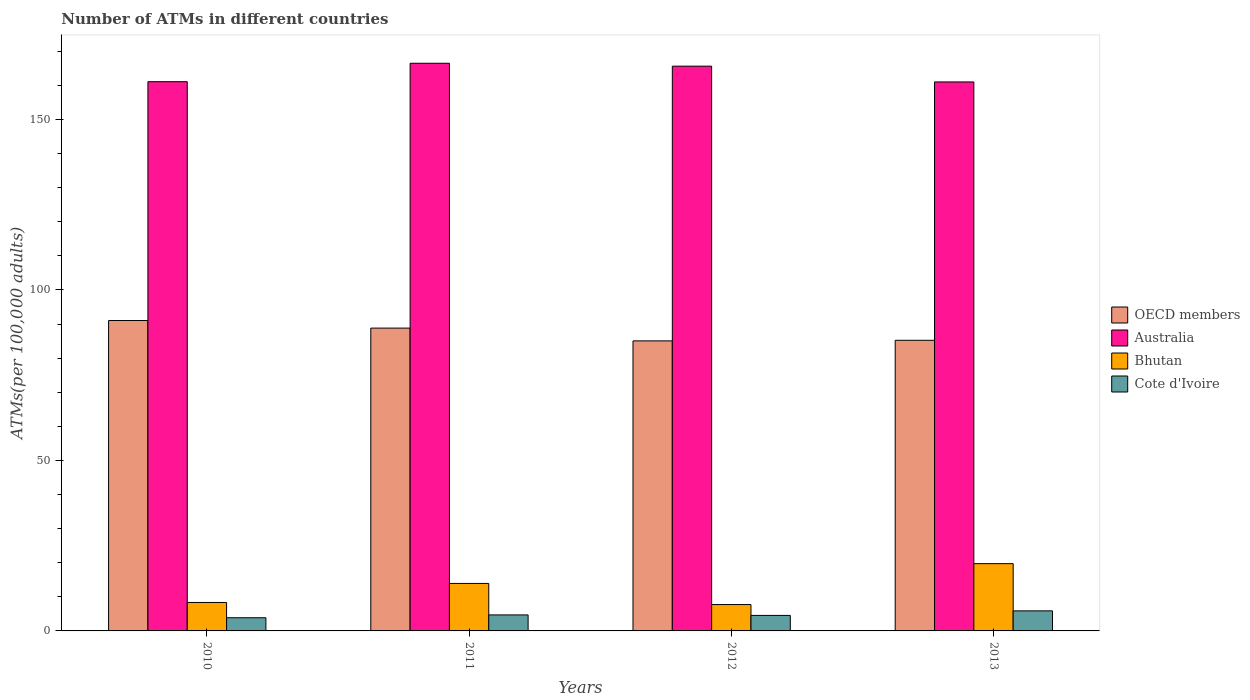How many different coloured bars are there?
Your answer should be very brief. 4. Are the number of bars on each tick of the X-axis equal?
Offer a terse response. Yes. How many bars are there on the 4th tick from the left?
Provide a succinct answer. 4. In how many cases, is the number of bars for a given year not equal to the number of legend labels?
Provide a short and direct response. 0. What is the number of ATMs in Bhutan in 2012?
Ensure brevity in your answer.  7.73. Across all years, what is the maximum number of ATMs in Bhutan?
Give a very brief answer. 19.73. Across all years, what is the minimum number of ATMs in Bhutan?
Your answer should be compact. 7.73. In which year was the number of ATMs in OECD members maximum?
Give a very brief answer. 2010. What is the total number of ATMs in OECD members in the graph?
Provide a succinct answer. 350.12. What is the difference between the number of ATMs in Bhutan in 2012 and that in 2013?
Ensure brevity in your answer.  -11.99. What is the difference between the number of ATMs in Cote d'Ivoire in 2010 and the number of ATMs in Australia in 2013?
Your response must be concise. -157.13. What is the average number of ATMs in Australia per year?
Ensure brevity in your answer.  163.54. In the year 2011, what is the difference between the number of ATMs in OECD members and number of ATMs in Cote d'Ivoire?
Your answer should be compact. 84.11. What is the ratio of the number of ATMs in Cote d'Ivoire in 2011 to that in 2013?
Your answer should be very brief. 0.8. Is the difference between the number of ATMs in OECD members in 2012 and 2013 greater than the difference between the number of ATMs in Cote d'Ivoire in 2012 and 2013?
Ensure brevity in your answer.  Yes. What is the difference between the highest and the second highest number of ATMs in Bhutan?
Give a very brief answer. 5.8. What is the difference between the highest and the lowest number of ATMs in OECD members?
Offer a very short reply. 5.97. Is the sum of the number of ATMs in Bhutan in 2010 and 2011 greater than the maximum number of ATMs in Cote d'Ivoire across all years?
Ensure brevity in your answer.  Yes. Is it the case that in every year, the sum of the number of ATMs in Australia and number of ATMs in Bhutan is greater than the sum of number of ATMs in OECD members and number of ATMs in Cote d'Ivoire?
Provide a short and direct response. Yes. Is it the case that in every year, the sum of the number of ATMs in OECD members and number of ATMs in Bhutan is greater than the number of ATMs in Australia?
Offer a terse response. No. What is the difference between two consecutive major ticks on the Y-axis?
Ensure brevity in your answer.  50. Are the values on the major ticks of Y-axis written in scientific E-notation?
Your answer should be compact. No. Does the graph contain grids?
Provide a succinct answer. No. How are the legend labels stacked?
Your answer should be compact. Vertical. What is the title of the graph?
Make the answer very short. Number of ATMs in different countries. What is the label or title of the Y-axis?
Offer a very short reply. ATMs(per 100,0 adults). What is the ATMs(per 100,000 adults) of OECD members in 2010?
Your answer should be very brief. 91.03. What is the ATMs(per 100,000 adults) of Australia in 2010?
Give a very brief answer. 161.07. What is the ATMs(per 100,000 adults) in Bhutan in 2010?
Your answer should be very brief. 8.34. What is the ATMs(per 100,000 adults) in Cote d'Ivoire in 2010?
Your answer should be very brief. 3.87. What is the ATMs(per 100,000 adults) in OECD members in 2011?
Your answer should be compact. 88.81. What is the ATMs(per 100,000 adults) in Australia in 2011?
Offer a terse response. 166.47. What is the ATMs(per 100,000 adults) in Bhutan in 2011?
Your answer should be very brief. 13.93. What is the ATMs(per 100,000 adults) in Cote d'Ivoire in 2011?
Keep it short and to the point. 4.69. What is the ATMs(per 100,000 adults) in OECD members in 2012?
Offer a very short reply. 85.06. What is the ATMs(per 100,000 adults) in Australia in 2012?
Offer a terse response. 165.62. What is the ATMs(per 100,000 adults) in Bhutan in 2012?
Keep it short and to the point. 7.73. What is the ATMs(per 100,000 adults) in Cote d'Ivoire in 2012?
Provide a short and direct response. 4.55. What is the ATMs(per 100,000 adults) in OECD members in 2013?
Make the answer very short. 85.23. What is the ATMs(per 100,000 adults) in Australia in 2013?
Your response must be concise. 160.99. What is the ATMs(per 100,000 adults) of Bhutan in 2013?
Provide a succinct answer. 19.73. What is the ATMs(per 100,000 adults) in Cote d'Ivoire in 2013?
Give a very brief answer. 5.88. Across all years, what is the maximum ATMs(per 100,000 adults) of OECD members?
Provide a succinct answer. 91.03. Across all years, what is the maximum ATMs(per 100,000 adults) in Australia?
Your answer should be very brief. 166.47. Across all years, what is the maximum ATMs(per 100,000 adults) in Bhutan?
Your answer should be compact. 19.73. Across all years, what is the maximum ATMs(per 100,000 adults) of Cote d'Ivoire?
Offer a very short reply. 5.88. Across all years, what is the minimum ATMs(per 100,000 adults) of OECD members?
Offer a terse response. 85.06. Across all years, what is the minimum ATMs(per 100,000 adults) in Australia?
Offer a terse response. 160.99. Across all years, what is the minimum ATMs(per 100,000 adults) of Bhutan?
Ensure brevity in your answer.  7.73. Across all years, what is the minimum ATMs(per 100,000 adults) of Cote d'Ivoire?
Make the answer very short. 3.87. What is the total ATMs(per 100,000 adults) of OECD members in the graph?
Your answer should be very brief. 350.12. What is the total ATMs(per 100,000 adults) in Australia in the graph?
Give a very brief answer. 654.16. What is the total ATMs(per 100,000 adults) of Bhutan in the graph?
Your response must be concise. 49.73. What is the total ATMs(per 100,000 adults) in Cote d'Ivoire in the graph?
Your response must be concise. 18.99. What is the difference between the ATMs(per 100,000 adults) in OECD members in 2010 and that in 2011?
Your response must be concise. 2.22. What is the difference between the ATMs(per 100,000 adults) in Australia in 2010 and that in 2011?
Offer a very short reply. -5.41. What is the difference between the ATMs(per 100,000 adults) in Bhutan in 2010 and that in 2011?
Your response must be concise. -5.59. What is the difference between the ATMs(per 100,000 adults) in Cote d'Ivoire in 2010 and that in 2011?
Offer a very short reply. -0.83. What is the difference between the ATMs(per 100,000 adults) in OECD members in 2010 and that in 2012?
Ensure brevity in your answer.  5.97. What is the difference between the ATMs(per 100,000 adults) of Australia in 2010 and that in 2012?
Make the answer very short. -4.55. What is the difference between the ATMs(per 100,000 adults) of Bhutan in 2010 and that in 2012?
Make the answer very short. 0.61. What is the difference between the ATMs(per 100,000 adults) in Cote d'Ivoire in 2010 and that in 2012?
Make the answer very short. -0.68. What is the difference between the ATMs(per 100,000 adults) of OECD members in 2010 and that in 2013?
Keep it short and to the point. 5.8. What is the difference between the ATMs(per 100,000 adults) of Australia in 2010 and that in 2013?
Your answer should be compact. 0.07. What is the difference between the ATMs(per 100,000 adults) in Bhutan in 2010 and that in 2013?
Provide a succinct answer. -11.39. What is the difference between the ATMs(per 100,000 adults) of Cote d'Ivoire in 2010 and that in 2013?
Your answer should be compact. -2.01. What is the difference between the ATMs(per 100,000 adults) of OECD members in 2011 and that in 2012?
Provide a succinct answer. 3.75. What is the difference between the ATMs(per 100,000 adults) in Australia in 2011 and that in 2012?
Offer a very short reply. 0.85. What is the difference between the ATMs(per 100,000 adults) of Bhutan in 2011 and that in 2012?
Make the answer very short. 6.19. What is the difference between the ATMs(per 100,000 adults) in Cote d'Ivoire in 2011 and that in 2012?
Provide a succinct answer. 0.15. What is the difference between the ATMs(per 100,000 adults) in OECD members in 2011 and that in 2013?
Your answer should be compact. 3.58. What is the difference between the ATMs(per 100,000 adults) in Australia in 2011 and that in 2013?
Your response must be concise. 5.48. What is the difference between the ATMs(per 100,000 adults) of Bhutan in 2011 and that in 2013?
Offer a very short reply. -5.8. What is the difference between the ATMs(per 100,000 adults) of Cote d'Ivoire in 2011 and that in 2013?
Your answer should be very brief. -1.19. What is the difference between the ATMs(per 100,000 adults) of OECD members in 2012 and that in 2013?
Provide a short and direct response. -0.17. What is the difference between the ATMs(per 100,000 adults) in Australia in 2012 and that in 2013?
Your response must be concise. 4.63. What is the difference between the ATMs(per 100,000 adults) of Bhutan in 2012 and that in 2013?
Provide a short and direct response. -11.99. What is the difference between the ATMs(per 100,000 adults) in Cote d'Ivoire in 2012 and that in 2013?
Offer a terse response. -1.33. What is the difference between the ATMs(per 100,000 adults) of OECD members in 2010 and the ATMs(per 100,000 adults) of Australia in 2011?
Provide a succinct answer. -75.44. What is the difference between the ATMs(per 100,000 adults) of OECD members in 2010 and the ATMs(per 100,000 adults) of Bhutan in 2011?
Your answer should be compact. 77.1. What is the difference between the ATMs(per 100,000 adults) of OECD members in 2010 and the ATMs(per 100,000 adults) of Cote d'Ivoire in 2011?
Ensure brevity in your answer.  86.34. What is the difference between the ATMs(per 100,000 adults) of Australia in 2010 and the ATMs(per 100,000 adults) of Bhutan in 2011?
Your response must be concise. 147.14. What is the difference between the ATMs(per 100,000 adults) of Australia in 2010 and the ATMs(per 100,000 adults) of Cote d'Ivoire in 2011?
Keep it short and to the point. 156.38. What is the difference between the ATMs(per 100,000 adults) in Bhutan in 2010 and the ATMs(per 100,000 adults) in Cote d'Ivoire in 2011?
Keep it short and to the point. 3.65. What is the difference between the ATMs(per 100,000 adults) of OECD members in 2010 and the ATMs(per 100,000 adults) of Australia in 2012?
Your response must be concise. -74.59. What is the difference between the ATMs(per 100,000 adults) of OECD members in 2010 and the ATMs(per 100,000 adults) of Bhutan in 2012?
Your response must be concise. 83.3. What is the difference between the ATMs(per 100,000 adults) of OECD members in 2010 and the ATMs(per 100,000 adults) of Cote d'Ivoire in 2012?
Make the answer very short. 86.48. What is the difference between the ATMs(per 100,000 adults) of Australia in 2010 and the ATMs(per 100,000 adults) of Bhutan in 2012?
Ensure brevity in your answer.  153.34. What is the difference between the ATMs(per 100,000 adults) of Australia in 2010 and the ATMs(per 100,000 adults) of Cote d'Ivoire in 2012?
Provide a succinct answer. 156.52. What is the difference between the ATMs(per 100,000 adults) of Bhutan in 2010 and the ATMs(per 100,000 adults) of Cote d'Ivoire in 2012?
Make the answer very short. 3.79. What is the difference between the ATMs(per 100,000 adults) of OECD members in 2010 and the ATMs(per 100,000 adults) of Australia in 2013?
Your answer should be very brief. -69.97. What is the difference between the ATMs(per 100,000 adults) in OECD members in 2010 and the ATMs(per 100,000 adults) in Bhutan in 2013?
Offer a terse response. 71.3. What is the difference between the ATMs(per 100,000 adults) in OECD members in 2010 and the ATMs(per 100,000 adults) in Cote d'Ivoire in 2013?
Ensure brevity in your answer.  85.15. What is the difference between the ATMs(per 100,000 adults) in Australia in 2010 and the ATMs(per 100,000 adults) in Bhutan in 2013?
Offer a very short reply. 141.34. What is the difference between the ATMs(per 100,000 adults) in Australia in 2010 and the ATMs(per 100,000 adults) in Cote d'Ivoire in 2013?
Provide a succinct answer. 155.19. What is the difference between the ATMs(per 100,000 adults) in Bhutan in 2010 and the ATMs(per 100,000 adults) in Cote d'Ivoire in 2013?
Keep it short and to the point. 2.46. What is the difference between the ATMs(per 100,000 adults) of OECD members in 2011 and the ATMs(per 100,000 adults) of Australia in 2012?
Your response must be concise. -76.82. What is the difference between the ATMs(per 100,000 adults) of OECD members in 2011 and the ATMs(per 100,000 adults) of Bhutan in 2012?
Offer a very short reply. 81.07. What is the difference between the ATMs(per 100,000 adults) of OECD members in 2011 and the ATMs(per 100,000 adults) of Cote d'Ivoire in 2012?
Your response must be concise. 84.26. What is the difference between the ATMs(per 100,000 adults) in Australia in 2011 and the ATMs(per 100,000 adults) in Bhutan in 2012?
Offer a very short reply. 158.74. What is the difference between the ATMs(per 100,000 adults) in Australia in 2011 and the ATMs(per 100,000 adults) in Cote d'Ivoire in 2012?
Keep it short and to the point. 161.93. What is the difference between the ATMs(per 100,000 adults) of Bhutan in 2011 and the ATMs(per 100,000 adults) of Cote d'Ivoire in 2012?
Keep it short and to the point. 9.38. What is the difference between the ATMs(per 100,000 adults) in OECD members in 2011 and the ATMs(per 100,000 adults) in Australia in 2013?
Give a very brief answer. -72.19. What is the difference between the ATMs(per 100,000 adults) of OECD members in 2011 and the ATMs(per 100,000 adults) of Bhutan in 2013?
Provide a short and direct response. 69.08. What is the difference between the ATMs(per 100,000 adults) of OECD members in 2011 and the ATMs(per 100,000 adults) of Cote d'Ivoire in 2013?
Give a very brief answer. 82.92. What is the difference between the ATMs(per 100,000 adults) in Australia in 2011 and the ATMs(per 100,000 adults) in Bhutan in 2013?
Make the answer very short. 146.75. What is the difference between the ATMs(per 100,000 adults) of Australia in 2011 and the ATMs(per 100,000 adults) of Cote d'Ivoire in 2013?
Give a very brief answer. 160.59. What is the difference between the ATMs(per 100,000 adults) in Bhutan in 2011 and the ATMs(per 100,000 adults) in Cote d'Ivoire in 2013?
Give a very brief answer. 8.04. What is the difference between the ATMs(per 100,000 adults) in OECD members in 2012 and the ATMs(per 100,000 adults) in Australia in 2013?
Give a very brief answer. -75.94. What is the difference between the ATMs(per 100,000 adults) in OECD members in 2012 and the ATMs(per 100,000 adults) in Bhutan in 2013?
Provide a short and direct response. 65.33. What is the difference between the ATMs(per 100,000 adults) in OECD members in 2012 and the ATMs(per 100,000 adults) in Cote d'Ivoire in 2013?
Offer a very short reply. 79.18. What is the difference between the ATMs(per 100,000 adults) of Australia in 2012 and the ATMs(per 100,000 adults) of Bhutan in 2013?
Give a very brief answer. 145.89. What is the difference between the ATMs(per 100,000 adults) in Australia in 2012 and the ATMs(per 100,000 adults) in Cote d'Ivoire in 2013?
Give a very brief answer. 159.74. What is the difference between the ATMs(per 100,000 adults) of Bhutan in 2012 and the ATMs(per 100,000 adults) of Cote d'Ivoire in 2013?
Ensure brevity in your answer.  1.85. What is the average ATMs(per 100,000 adults) in OECD members per year?
Offer a terse response. 87.53. What is the average ATMs(per 100,000 adults) of Australia per year?
Ensure brevity in your answer.  163.54. What is the average ATMs(per 100,000 adults) in Bhutan per year?
Keep it short and to the point. 12.43. What is the average ATMs(per 100,000 adults) of Cote d'Ivoire per year?
Make the answer very short. 4.75. In the year 2010, what is the difference between the ATMs(per 100,000 adults) in OECD members and ATMs(per 100,000 adults) in Australia?
Keep it short and to the point. -70.04. In the year 2010, what is the difference between the ATMs(per 100,000 adults) in OECD members and ATMs(per 100,000 adults) in Bhutan?
Keep it short and to the point. 82.69. In the year 2010, what is the difference between the ATMs(per 100,000 adults) in OECD members and ATMs(per 100,000 adults) in Cote d'Ivoire?
Your answer should be very brief. 87.16. In the year 2010, what is the difference between the ATMs(per 100,000 adults) in Australia and ATMs(per 100,000 adults) in Bhutan?
Offer a terse response. 152.73. In the year 2010, what is the difference between the ATMs(per 100,000 adults) of Australia and ATMs(per 100,000 adults) of Cote d'Ivoire?
Provide a succinct answer. 157.2. In the year 2010, what is the difference between the ATMs(per 100,000 adults) in Bhutan and ATMs(per 100,000 adults) in Cote d'Ivoire?
Provide a succinct answer. 4.47. In the year 2011, what is the difference between the ATMs(per 100,000 adults) in OECD members and ATMs(per 100,000 adults) in Australia?
Provide a succinct answer. -77.67. In the year 2011, what is the difference between the ATMs(per 100,000 adults) in OECD members and ATMs(per 100,000 adults) in Bhutan?
Give a very brief answer. 74.88. In the year 2011, what is the difference between the ATMs(per 100,000 adults) of OECD members and ATMs(per 100,000 adults) of Cote d'Ivoire?
Your answer should be compact. 84.11. In the year 2011, what is the difference between the ATMs(per 100,000 adults) in Australia and ATMs(per 100,000 adults) in Bhutan?
Offer a terse response. 152.55. In the year 2011, what is the difference between the ATMs(per 100,000 adults) in Australia and ATMs(per 100,000 adults) in Cote d'Ivoire?
Keep it short and to the point. 161.78. In the year 2011, what is the difference between the ATMs(per 100,000 adults) of Bhutan and ATMs(per 100,000 adults) of Cote d'Ivoire?
Give a very brief answer. 9.23. In the year 2012, what is the difference between the ATMs(per 100,000 adults) in OECD members and ATMs(per 100,000 adults) in Australia?
Provide a succinct answer. -80.56. In the year 2012, what is the difference between the ATMs(per 100,000 adults) of OECD members and ATMs(per 100,000 adults) of Bhutan?
Provide a short and direct response. 77.32. In the year 2012, what is the difference between the ATMs(per 100,000 adults) in OECD members and ATMs(per 100,000 adults) in Cote d'Ivoire?
Ensure brevity in your answer.  80.51. In the year 2012, what is the difference between the ATMs(per 100,000 adults) in Australia and ATMs(per 100,000 adults) in Bhutan?
Provide a succinct answer. 157.89. In the year 2012, what is the difference between the ATMs(per 100,000 adults) of Australia and ATMs(per 100,000 adults) of Cote d'Ivoire?
Give a very brief answer. 161.07. In the year 2012, what is the difference between the ATMs(per 100,000 adults) in Bhutan and ATMs(per 100,000 adults) in Cote d'Ivoire?
Keep it short and to the point. 3.19. In the year 2013, what is the difference between the ATMs(per 100,000 adults) of OECD members and ATMs(per 100,000 adults) of Australia?
Offer a terse response. -75.77. In the year 2013, what is the difference between the ATMs(per 100,000 adults) of OECD members and ATMs(per 100,000 adults) of Bhutan?
Offer a terse response. 65.5. In the year 2013, what is the difference between the ATMs(per 100,000 adults) in OECD members and ATMs(per 100,000 adults) in Cote d'Ivoire?
Your answer should be compact. 79.34. In the year 2013, what is the difference between the ATMs(per 100,000 adults) in Australia and ATMs(per 100,000 adults) in Bhutan?
Provide a succinct answer. 141.27. In the year 2013, what is the difference between the ATMs(per 100,000 adults) in Australia and ATMs(per 100,000 adults) in Cote d'Ivoire?
Keep it short and to the point. 155.11. In the year 2013, what is the difference between the ATMs(per 100,000 adults) of Bhutan and ATMs(per 100,000 adults) of Cote d'Ivoire?
Keep it short and to the point. 13.85. What is the ratio of the ATMs(per 100,000 adults) of OECD members in 2010 to that in 2011?
Ensure brevity in your answer.  1.02. What is the ratio of the ATMs(per 100,000 adults) of Australia in 2010 to that in 2011?
Keep it short and to the point. 0.97. What is the ratio of the ATMs(per 100,000 adults) in Bhutan in 2010 to that in 2011?
Keep it short and to the point. 0.6. What is the ratio of the ATMs(per 100,000 adults) in Cote d'Ivoire in 2010 to that in 2011?
Your response must be concise. 0.82. What is the ratio of the ATMs(per 100,000 adults) of OECD members in 2010 to that in 2012?
Provide a short and direct response. 1.07. What is the ratio of the ATMs(per 100,000 adults) in Australia in 2010 to that in 2012?
Ensure brevity in your answer.  0.97. What is the ratio of the ATMs(per 100,000 adults) in Bhutan in 2010 to that in 2012?
Provide a succinct answer. 1.08. What is the ratio of the ATMs(per 100,000 adults) of Cote d'Ivoire in 2010 to that in 2012?
Provide a short and direct response. 0.85. What is the ratio of the ATMs(per 100,000 adults) in OECD members in 2010 to that in 2013?
Keep it short and to the point. 1.07. What is the ratio of the ATMs(per 100,000 adults) of Bhutan in 2010 to that in 2013?
Offer a terse response. 0.42. What is the ratio of the ATMs(per 100,000 adults) in Cote d'Ivoire in 2010 to that in 2013?
Your answer should be very brief. 0.66. What is the ratio of the ATMs(per 100,000 adults) of OECD members in 2011 to that in 2012?
Provide a succinct answer. 1.04. What is the ratio of the ATMs(per 100,000 adults) of Bhutan in 2011 to that in 2012?
Provide a succinct answer. 1.8. What is the ratio of the ATMs(per 100,000 adults) in Cote d'Ivoire in 2011 to that in 2012?
Offer a very short reply. 1.03. What is the ratio of the ATMs(per 100,000 adults) in OECD members in 2011 to that in 2013?
Offer a terse response. 1.04. What is the ratio of the ATMs(per 100,000 adults) in Australia in 2011 to that in 2013?
Ensure brevity in your answer.  1.03. What is the ratio of the ATMs(per 100,000 adults) of Bhutan in 2011 to that in 2013?
Give a very brief answer. 0.71. What is the ratio of the ATMs(per 100,000 adults) of Cote d'Ivoire in 2011 to that in 2013?
Offer a terse response. 0.8. What is the ratio of the ATMs(per 100,000 adults) in Australia in 2012 to that in 2013?
Provide a succinct answer. 1.03. What is the ratio of the ATMs(per 100,000 adults) in Bhutan in 2012 to that in 2013?
Provide a short and direct response. 0.39. What is the ratio of the ATMs(per 100,000 adults) of Cote d'Ivoire in 2012 to that in 2013?
Provide a succinct answer. 0.77. What is the difference between the highest and the second highest ATMs(per 100,000 adults) of OECD members?
Provide a short and direct response. 2.22. What is the difference between the highest and the second highest ATMs(per 100,000 adults) of Australia?
Your response must be concise. 0.85. What is the difference between the highest and the second highest ATMs(per 100,000 adults) in Bhutan?
Offer a very short reply. 5.8. What is the difference between the highest and the second highest ATMs(per 100,000 adults) in Cote d'Ivoire?
Keep it short and to the point. 1.19. What is the difference between the highest and the lowest ATMs(per 100,000 adults) in OECD members?
Your answer should be very brief. 5.97. What is the difference between the highest and the lowest ATMs(per 100,000 adults) of Australia?
Give a very brief answer. 5.48. What is the difference between the highest and the lowest ATMs(per 100,000 adults) in Bhutan?
Your answer should be compact. 11.99. What is the difference between the highest and the lowest ATMs(per 100,000 adults) of Cote d'Ivoire?
Provide a short and direct response. 2.01. 